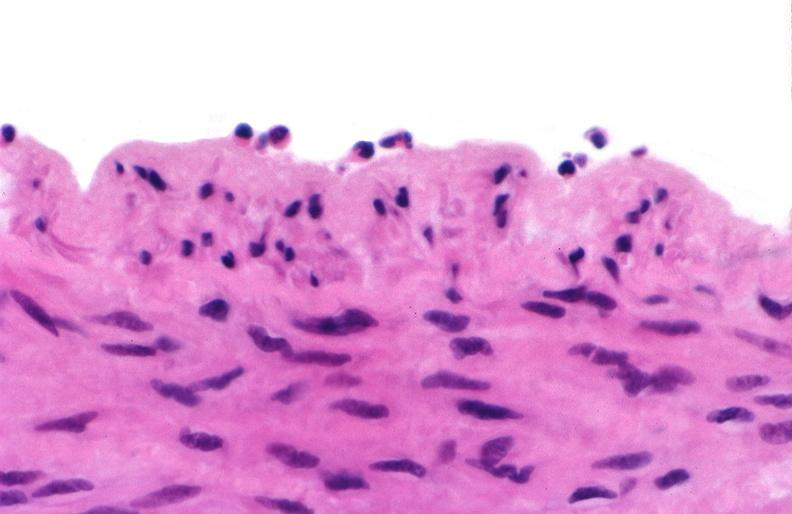what does this image show?
Answer the question using a single word or phrase. Acute inflammation 